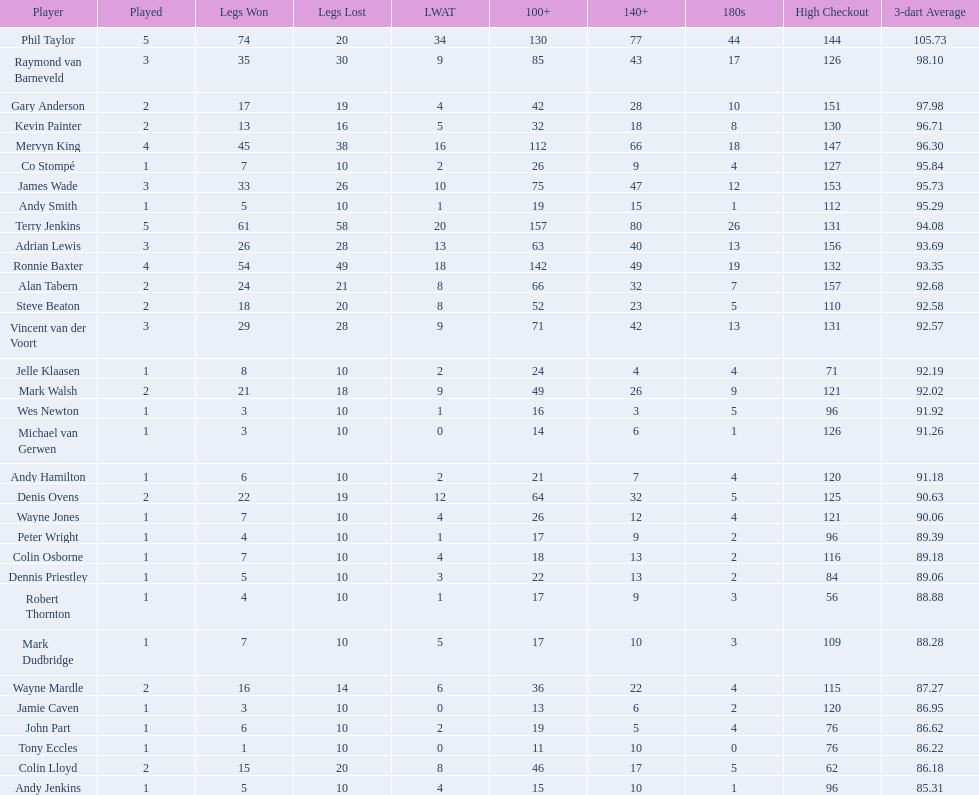How many contestants won 30 or more legs in the 2009 world matchplay? 6. 